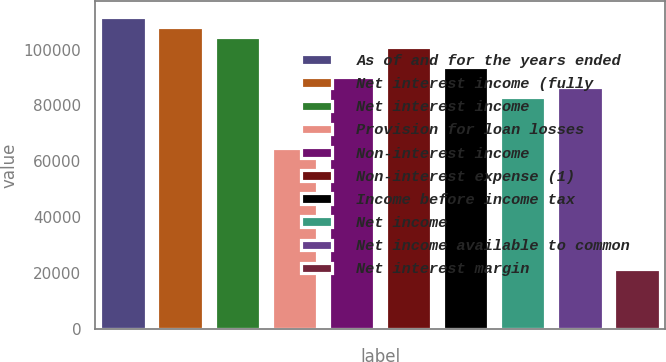<chart> <loc_0><loc_0><loc_500><loc_500><bar_chart><fcel>As of and for the years ended<fcel>Net interest income (fully<fcel>Net interest income<fcel>Provision for loan losses<fcel>Non-interest income<fcel>Non-interest expense (1)<fcel>Income before income tax<fcel>Net income<fcel>Net income available to common<fcel>Net interest margin<nl><fcel>111668<fcel>108066<fcel>104464<fcel>64839.5<fcel>90054.9<fcel>100861<fcel>93657.1<fcel>82850.5<fcel>86452.7<fcel>21613.3<nl></chart> 